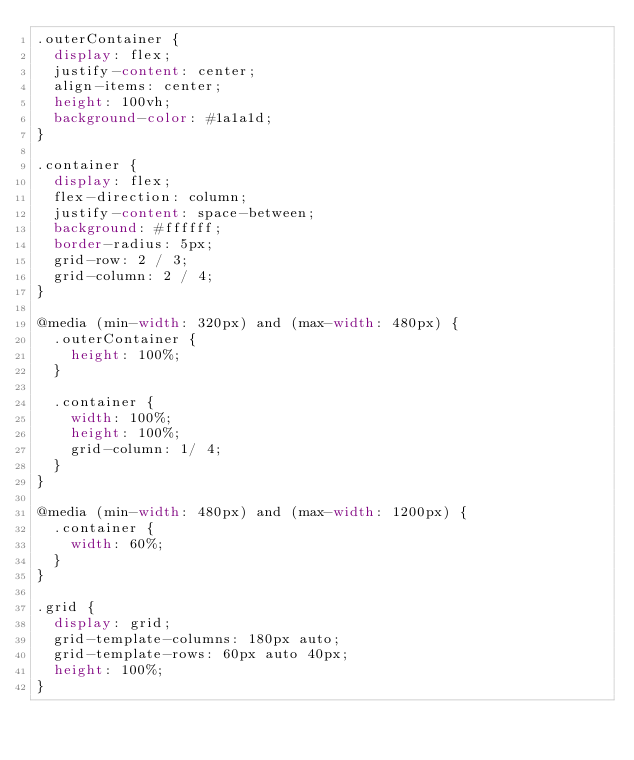Convert code to text. <code><loc_0><loc_0><loc_500><loc_500><_CSS_>.outerContainer {
	display: flex;
	justify-content: center;
	align-items: center;
	height: 100vh;
	background-color: #1a1a1d;
}

.container {
	display: flex;
	flex-direction: column;
	justify-content: space-between;
	background: #ffffff;
	border-radius: 5px;
	grid-row: 2 / 3;
	grid-column: 2 / 4;
}

@media (min-width: 320px) and (max-width: 480px) {
	.outerContainer {
		height: 100%;
	}

	.container {
		width: 100%;
		height: 100%;
		grid-column: 1/ 4;
	}
}

@media (min-width: 480px) and (max-width: 1200px) {
	.container {
		width: 60%;
	}
}

.grid {
	display: grid;
	grid-template-columns: 180px auto;
	grid-template-rows: 60px auto 40px;
	height: 100%;
}</code> 